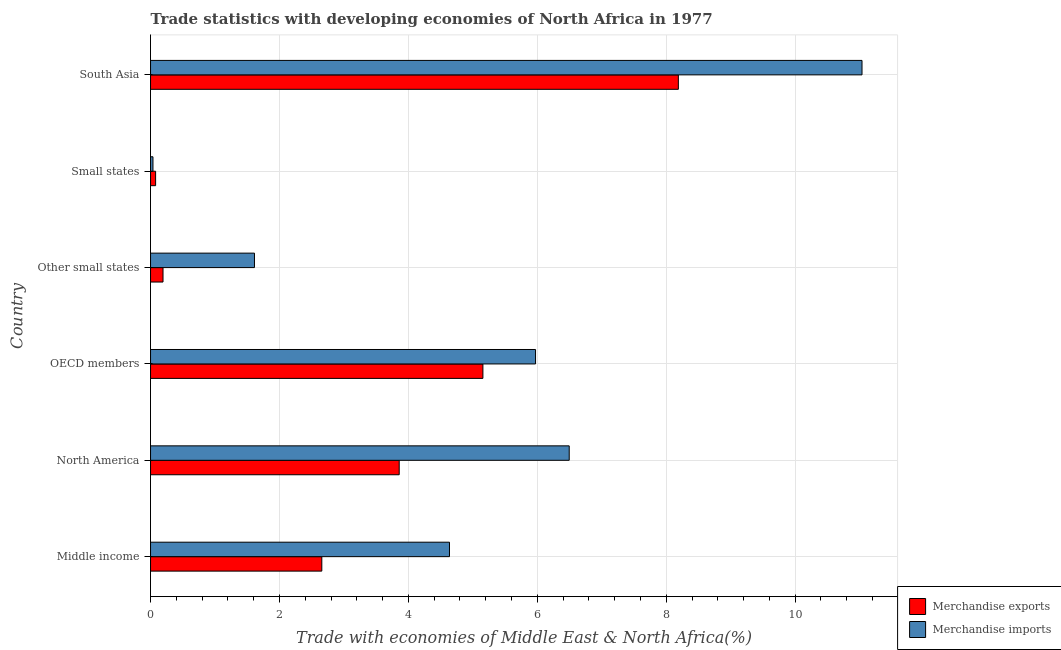How many groups of bars are there?
Your answer should be compact. 6. Are the number of bars per tick equal to the number of legend labels?
Offer a very short reply. Yes. Are the number of bars on each tick of the Y-axis equal?
Provide a short and direct response. Yes. How many bars are there on the 3rd tick from the bottom?
Keep it short and to the point. 2. In how many cases, is the number of bars for a given country not equal to the number of legend labels?
Your answer should be very brief. 0. What is the merchandise imports in North America?
Ensure brevity in your answer.  6.49. Across all countries, what is the maximum merchandise exports?
Ensure brevity in your answer.  8.19. Across all countries, what is the minimum merchandise exports?
Ensure brevity in your answer.  0.08. In which country was the merchandise exports maximum?
Make the answer very short. South Asia. In which country was the merchandise exports minimum?
Ensure brevity in your answer.  Small states. What is the total merchandise imports in the graph?
Provide a succinct answer. 29.79. What is the difference between the merchandise imports in OECD members and that in Small states?
Keep it short and to the point. 5.93. What is the difference between the merchandise imports in Middle income and the merchandise exports in North America?
Provide a short and direct response. 0.78. What is the average merchandise imports per country?
Your response must be concise. 4.96. What is the difference between the merchandise exports and merchandise imports in South Asia?
Ensure brevity in your answer.  -2.85. In how many countries, is the merchandise exports greater than 5.2 %?
Your answer should be very brief. 1. What is the ratio of the merchandise exports in Middle income to that in OECD members?
Your answer should be very brief. 0.52. Is the merchandise exports in Middle income less than that in Small states?
Make the answer very short. No. What is the difference between the highest and the second highest merchandise exports?
Offer a very short reply. 3.03. What is the difference between the highest and the lowest merchandise imports?
Your answer should be very brief. 11. What does the 2nd bar from the bottom in OECD members represents?
Provide a short and direct response. Merchandise imports. How many bars are there?
Provide a succinct answer. 12. Are all the bars in the graph horizontal?
Make the answer very short. Yes. Are the values on the major ticks of X-axis written in scientific E-notation?
Make the answer very short. No. Does the graph contain any zero values?
Give a very brief answer. No. Does the graph contain grids?
Make the answer very short. Yes. Where does the legend appear in the graph?
Offer a terse response. Bottom right. What is the title of the graph?
Your answer should be compact. Trade statistics with developing economies of North Africa in 1977. What is the label or title of the X-axis?
Offer a terse response. Trade with economies of Middle East & North Africa(%). What is the Trade with economies of Middle East & North Africa(%) of Merchandise exports in Middle income?
Ensure brevity in your answer.  2.66. What is the Trade with economies of Middle East & North Africa(%) in Merchandise imports in Middle income?
Ensure brevity in your answer.  4.64. What is the Trade with economies of Middle East & North Africa(%) in Merchandise exports in North America?
Provide a short and direct response. 3.86. What is the Trade with economies of Middle East & North Africa(%) in Merchandise imports in North America?
Your response must be concise. 6.49. What is the Trade with economies of Middle East & North Africa(%) of Merchandise exports in OECD members?
Offer a very short reply. 5.16. What is the Trade with economies of Middle East & North Africa(%) of Merchandise imports in OECD members?
Your answer should be very brief. 5.97. What is the Trade with economies of Middle East & North Africa(%) of Merchandise exports in Other small states?
Your answer should be very brief. 0.19. What is the Trade with economies of Middle East & North Africa(%) of Merchandise imports in Other small states?
Ensure brevity in your answer.  1.61. What is the Trade with economies of Middle East & North Africa(%) in Merchandise exports in Small states?
Make the answer very short. 0.08. What is the Trade with economies of Middle East & North Africa(%) of Merchandise imports in Small states?
Your answer should be compact. 0.04. What is the Trade with economies of Middle East & North Africa(%) in Merchandise exports in South Asia?
Give a very brief answer. 8.19. What is the Trade with economies of Middle East & North Africa(%) of Merchandise imports in South Asia?
Your answer should be compact. 11.04. Across all countries, what is the maximum Trade with economies of Middle East & North Africa(%) in Merchandise exports?
Your answer should be compact. 8.19. Across all countries, what is the maximum Trade with economies of Middle East & North Africa(%) in Merchandise imports?
Your response must be concise. 11.04. Across all countries, what is the minimum Trade with economies of Middle East & North Africa(%) of Merchandise exports?
Make the answer very short. 0.08. Across all countries, what is the minimum Trade with economies of Middle East & North Africa(%) of Merchandise imports?
Your response must be concise. 0.04. What is the total Trade with economies of Middle East & North Africa(%) of Merchandise exports in the graph?
Keep it short and to the point. 20.13. What is the total Trade with economies of Middle East & North Africa(%) of Merchandise imports in the graph?
Offer a terse response. 29.79. What is the difference between the Trade with economies of Middle East & North Africa(%) in Merchandise exports in Middle income and that in North America?
Make the answer very short. -1.2. What is the difference between the Trade with economies of Middle East & North Africa(%) of Merchandise imports in Middle income and that in North America?
Keep it short and to the point. -1.86. What is the difference between the Trade with economies of Middle East & North Africa(%) in Merchandise exports in Middle income and that in OECD members?
Give a very brief answer. -2.5. What is the difference between the Trade with economies of Middle East & North Africa(%) of Merchandise imports in Middle income and that in OECD members?
Give a very brief answer. -1.33. What is the difference between the Trade with economies of Middle East & North Africa(%) of Merchandise exports in Middle income and that in Other small states?
Keep it short and to the point. 2.46. What is the difference between the Trade with economies of Middle East & North Africa(%) in Merchandise imports in Middle income and that in Other small states?
Make the answer very short. 3.03. What is the difference between the Trade with economies of Middle East & North Africa(%) of Merchandise exports in Middle income and that in Small states?
Your answer should be compact. 2.58. What is the difference between the Trade with economies of Middle East & North Africa(%) of Merchandise imports in Middle income and that in Small states?
Offer a very short reply. 4.6. What is the difference between the Trade with economies of Middle East & North Africa(%) of Merchandise exports in Middle income and that in South Asia?
Your response must be concise. -5.53. What is the difference between the Trade with economies of Middle East & North Africa(%) in Merchandise imports in Middle income and that in South Asia?
Ensure brevity in your answer.  -6.4. What is the difference between the Trade with economies of Middle East & North Africa(%) of Merchandise exports in North America and that in OECD members?
Provide a succinct answer. -1.3. What is the difference between the Trade with economies of Middle East & North Africa(%) in Merchandise imports in North America and that in OECD members?
Offer a terse response. 0.52. What is the difference between the Trade with economies of Middle East & North Africa(%) in Merchandise exports in North America and that in Other small states?
Provide a short and direct response. 3.66. What is the difference between the Trade with economies of Middle East & North Africa(%) in Merchandise imports in North America and that in Other small states?
Your response must be concise. 4.88. What is the difference between the Trade with economies of Middle East & North Africa(%) in Merchandise exports in North America and that in Small states?
Your answer should be very brief. 3.78. What is the difference between the Trade with economies of Middle East & North Africa(%) in Merchandise imports in North America and that in Small states?
Provide a short and direct response. 6.46. What is the difference between the Trade with economies of Middle East & North Africa(%) of Merchandise exports in North America and that in South Asia?
Your response must be concise. -4.33. What is the difference between the Trade with economies of Middle East & North Africa(%) in Merchandise imports in North America and that in South Asia?
Keep it short and to the point. -4.54. What is the difference between the Trade with economies of Middle East & North Africa(%) in Merchandise exports in OECD members and that in Other small states?
Keep it short and to the point. 4.96. What is the difference between the Trade with economies of Middle East & North Africa(%) in Merchandise imports in OECD members and that in Other small states?
Offer a very short reply. 4.36. What is the difference between the Trade with economies of Middle East & North Africa(%) in Merchandise exports in OECD members and that in Small states?
Your response must be concise. 5.08. What is the difference between the Trade with economies of Middle East & North Africa(%) in Merchandise imports in OECD members and that in Small states?
Give a very brief answer. 5.93. What is the difference between the Trade with economies of Middle East & North Africa(%) of Merchandise exports in OECD members and that in South Asia?
Offer a terse response. -3.03. What is the difference between the Trade with economies of Middle East & North Africa(%) of Merchandise imports in OECD members and that in South Asia?
Provide a succinct answer. -5.06. What is the difference between the Trade with economies of Middle East & North Africa(%) in Merchandise exports in Other small states and that in Small states?
Your answer should be compact. 0.11. What is the difference between the Trade with economies of Middle East & North Africa(%) of Merchandise imports in Other small states and that in Small states?
Your response must be concise. 1.57. What is the difference between the Trade with economies of Middle East & North Africa(%) in Merchandise exports in Other small states and that in South Asia?
Your response must be concise. -7.99. What is the difference between the Trade with economies of Middle East & North Africa(%) in Merchandise imports in Other small states and that in South Asia?
Give a very brief answer. -9.42. What is the difference between the Trade with economies of Middle East & North Africa(%) in Merchandise exports in Small states and that in South Asia?
Ensure brevity in your answer.  -8.11. What is the difference between the Trade with economies of Middle East & North Africa(%) in Merchandise imports in Small states and that in South Asia?
Keep it short and to the point. -11. What is the difference between the Trade with economies of Middle East & North Africa(%) of Merchandise exports in Middle income and the Trade with economies of Middle East & North Africa(%) of Merchandise imports in North America?
Your answer should be compact. -3.84. What is the difference between the Trade with economies of Middle East & North Africa(%) in Merchandise exports in Middle income and the Trade with economies of Middle East & North Africa(%) in Merchandise imports in OECD members?
Your response must be concise. -3.32. What is the difference between the Trade with economies of Middle East & North Africa(%) of Merchandise exports in Middle income and the Trade with economies of Middle East & North Africa(%) of Merchandise imports in Other small states?
Make the answer very short. 1.04. What is the difference between the Trade with economies of Middle East & North Africa(%) of Merchandise exports in Middle income and the Trade with economies of Middle East & North Africa(%) of Merchandise imports in Small states?
Offer a very short reply. 2.62. What is the difference between the Trade with economies of Middle East & North Africa(%) of Merchandise exports in Middle income and the Trade with economies of Middle East & North Africa(%) of Merchandise imports in South Asia?
Make the answer very short. -8.38. What is the difference between the Trade with economies of Middle East & North Africa(%) in Merchandise exports in North America and the Trade with economies of Middle East & North Africa(%) in Merchandise imports in OECD members?
Offer a terse response. -2.12. What is the difference between the Trade with economies of Middle East & North Africa(%) in Merchandise exports in North America and the Trade with economies of Middle East & North Africa(%) in Merchandise imports in Other small states?
Offer a terse response. 2.25. What is the difference between the Trade with economies of Middle East & North Africa(%) of Merchandise exports in North America and the Trade with economies of Middle East & North Africa(%) of Merchandise imports in Small states?
Your response must be concise. 3.82. What is the difference between the Trade with economies of Middle East & North Africa(%) of Merchandise exports in North America and the Trade with economies of Middle East & North Africa(%) of Merchandise imports in South Asia?
Provide a short and direct response. -7.18. What is the difference between the Trade with economies of Middle East & North Africa(%) in Merchandise exports in OECD members and the Trade with economies of Middle East & North Africa(%) in Merchandise imports in Other small states?
Your answer should be very brief. 3.54. What is the difference between the Trade with economies of Middle East & North Africa(%) in Merchandise exports in OECD members and the Trade with economies of Middle East & North Africa(%) in Merchandise imports in Small states?
Give a very brief answer. 5.12. What is the difference between the Trade with economies of Middle East & North Africa(%) in Merchandise exports in OECD members and the Trade with economies of Middle East & North Africa(%) in Merchandise imports in South Asia?
Your answer should be very brief. -5.88. What is the difference between the Trade with economies of Middle East & North Africa(%) of Merchandise exports in Other small states and the Trade with economies of Middle East & North Africa(%) of Merchandise imports in Small states?
Offer a terse response. 0.16. What is the difference between the Trade with economies of Middle East & North Africa(%) in Merchandise exports in Other small states and the Trade with economies of Middle East & North Africa(%) in Merchandise imports in South Asia?
Make the answer very short. -10.84. What is the difference between the Trade with economies of Middle East & North Africa(%) in Merchandise exports in Small states and the Trade with economies of Middle East & North Africa(%) in Merchandise imports in South Asia?
Give a very brief answer. -10.96. What is the average Trade with economies of Middle East & North Africa(%) of Merchandise exports per country?
Your response must be concise. 3.35. What is the average Trade with economies of Middle East & North Africa(%) in Merchandise imports per country?
Ensure brevity in your answer.  4.97. What is the difference between the Trade with economies of Middle East & North Africa(%) of Merchandise exports and Trade with economies of Middle East & North Africa(%) of Merchandise imports in Middle income?
Your response must be concise. -1.98. What is the difference between the Trade with economies of Middle East & North Africa(%) in Merchandise exports and Trade with economies of Middle East & North Africa(%) in Merchandise imports in North America?
Provide a succinct answer. -2.64. What is the difference between the Trade with economies of Middle East & North Africa(%) in Merchandise exports and Trade with economies of Middle East & North Africa(%) in Merchandise imports in OECD members?
Give a very brief answer. -0.82. What is the difference between the Trade with economies of Middle East & North Africa(%) of Merchandise exports and Trade with economies of Middle East & North Africa(%) of Merchandise imports in Other small states?
Give a very brief answer. -1.42. What is the difference between the Trade with economies of Middle East & North Africa(%) in Merchandise exports and Trade with economies of Middle East & North Africa(%) in Merchandise imports in Small states?
Make the answer very short. 0.04. What is the difference between the Trade with economies of Middle East & North Africa(%) in Merchandise exports and Trade with economies of Middle East & North Africa(%) in Merchandise imports in South Asia?
Keep it short and to the point. -2.85. What is the ratio of the Trade with economies of Middle East & North Africa(%) of Merchandise exports in Middle income to that in North America?
Offer a very short reply. 0.69. What is the ratio of the Trade with economies of Middle East & North Africa(%) of Merchandise imports in Middle income to that in North America?
Provide a short and direct response. 0.71. What is the ratio of the Trade with economies of Middle East & North Africa(%) of Merchandise exports in Middle income to that in OECD members?
Provide a succinct answer. 0.52. What is the ratio of the Trade with economies of Middle East & North Africa(%) in Merchandise imports in Middle income to that in OECD members?
Give a very brief answer. 0.78. What is the ratio of the Trade with economies of Middle East & North Africa(%) in Merchandise exports in Middle income to that in Other small states?
Provide a short and direct response. 13.73. What is the ratio of the Trade with economies of Middle East & North Africa(%) in Merchandise imports in Middle income to that in Other small states?
Give a very brief answer. 2.88. What is the ratio of the Trade with economies of Middle East & North Africa(%) in Merchandise exports in Middle income to that in Small states?
Offer a terse response. 33.75. What is the ratio of the Trade with economies of Middle East & North Africa(%) in Merchandise imports in Middle income to that in Small states?
Ensure brevity in your answer.  122.75. What is the ratio of the Trade with economies of Middle East & North Africa(%) in Merchandise exports in Middle income to that in South Asia?
Give a very brief answer. 0.32. What is the ratio of the Trade with economies of Middle East & North Africa(%) of Merchandise imports in Middle income to that in South Asia?
Provide a short and direct response. 0.42. What is the ratio of the Trade with economies of Middle East & North Africa(%) in Merchandise exports in North America to that in OECD members?
Make the answer very short. 0.75. What is the ratio of the Trade with economies of Middle East & North Africa(%) of Merchandise imports in North America to that in OECD members?
Ensure brevity in your answer.  1.09. What is the ratio of the Trade with economies of Middle East & North Africa(%) of Merchandise exports in North America to that in Other small states?
Provide a succinct answer. 19.93. What is the ratio of the Trade with economies of Middle East & North Africa(%) in Merchandise imports in North America to that in Other small states?
Offer a terse response. 4.03. What is the ratio of the Trade with economies of Middle East & North Africa(%) of Merchandise exports in North America to that in Small states?
Make the answer very short. 49. What is the ratio of the Trade with economies of Middle East & North Africa(%) of Merchandise imports in North America to that in Small states?
Your answer should be very brief. 171.91. What is the ratio of the Trade with economies of Middle East & North Africa(%) in Merchandise exports in North America to that in South Asia?
Your answer should be very brief. 0.47. What is the ratio of the Trade with economies of Middle East & North Africa(%) of Merchandise imports in North America to that in South Asia?
Offer a terse response. 0.59. What is the ratio of the Trade with economies of Middle East & North Africa(%) in Merchandise exports in OECD members to that in Other small states?
Provide a short and direct response. 26.64. What is the ratio of the Trade with economies of Middle East & North Africa(%) of Merchandise imports in OECD members to that in Other small states?
Keep it short and to the point. 3.7. What is the ratio of the Trade with economies of Middle East & North Africa(%) in Merchandise exports in OECD members to that in Small states?
Keep it short and to the point. 65.49. What is the ratio of the Trade with economies of Middle East & North Africa(%) in Merchandise imports in OECD members to that in Small states?
Provide a succinct answer. 158.09. What is the ratio of the Trade with economies of Middle East & North Africa(%) in Merchandise exports in OECD members to that in South Asia?
Offer a very short reply. 0.63. What is the ratio of the Trade with economies of Middle East & North Africa(%) of Merchandise imports in OECD members to that in South Asia?
Your response must be concise. 0.54. What is the ratio of the Trade with economies of Middle East & North Africa(%) of Merchandise exports in Other small states to that in Small states?
Offer a terse response. 2.46. What is the ratio of the Trade with economies of Middle East & North Africa(%) of Merchandise imports in Other small states to that in Small states?
Your answer should be compact. 42.67. What is the ratio of the Trade with economies of Middle East & North Africa(%) of Merchandise exports in Other small states to that in South Asia?
Keep it short and to the point. 0.02. What is the ratio of the Trade with economies of Middle East & North Africa(%) of Merchandise imports in Other small states to that in South Asia?
Provide a succinct answer. 0.15. What is the ratio of the Trade with economies of Middle East & North Africa(%) in Merchandise exports in Small states to that in South Asia?
Provide a short and direct response. 0.01. What is the ratio of the Trade with economies of Middle East & North Africa(%) of Merchandise imports in Small states to that in South Asia?
Give a very brief answer. 0. What is the difference between the highest and the second highest Trade with economies of Middle East & North Africa(%) of Merchandise exports?
Ensure brevity in your answer.  3.03. What is the difference between the highest and the second highest Trade with economies of Middle East & North Africa(%) in Merchandise imports?
Your answer should be compact. 4.54. What is the difference between the highest and the lowest Trade with economies of Middle East & North Africa(%) in Merchandise exports?
Your response must be concise. 8.11. What is the difference between the highest and the lowest Trade with economies of Middle East & North Africa(%) of Merchandise imports?
Make the answer very short. 11. 